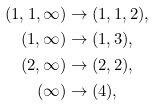Convert formula to latex. <formula><loc_0><loc_0><loc_500><loc_500>( 1 , 1 , \infty ) & \to ( 1 , 1 , 2 ) , \\ ( 1 , \infty ) & \to ( 1 , 3 ) , \\ ( 2 , \infty ) & \to ( 2 , 2 ) , \\ ( \infty ) & \to ( 4 ) ,</formula> 